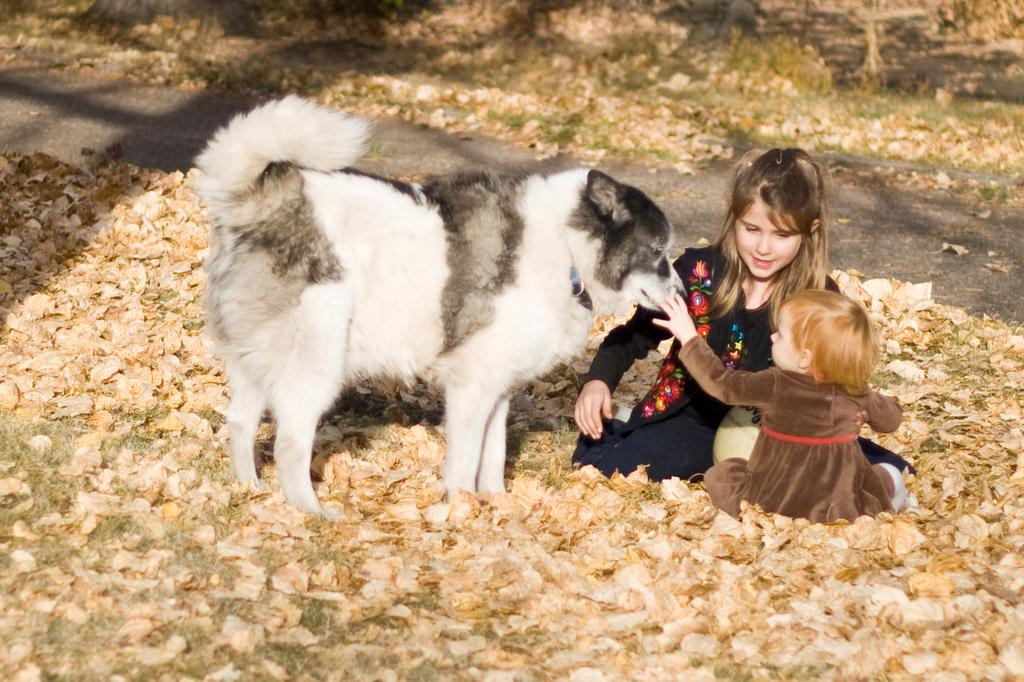Who is present in the image? There is a girl and a baby girl in the image. What are the girl and the baby girl doing in the image? Both the girl and the baby girl are sitting on the floor. What is the baby girl interacting with in the image? The baby girl is touching a dog. How many mice are present in the image? There are no mice present in the image. Who is the manager of the baby girl in the image? The concept of a manager does not apply to the baby girl in the image, as it is a photograph and not a workplace scenario. 